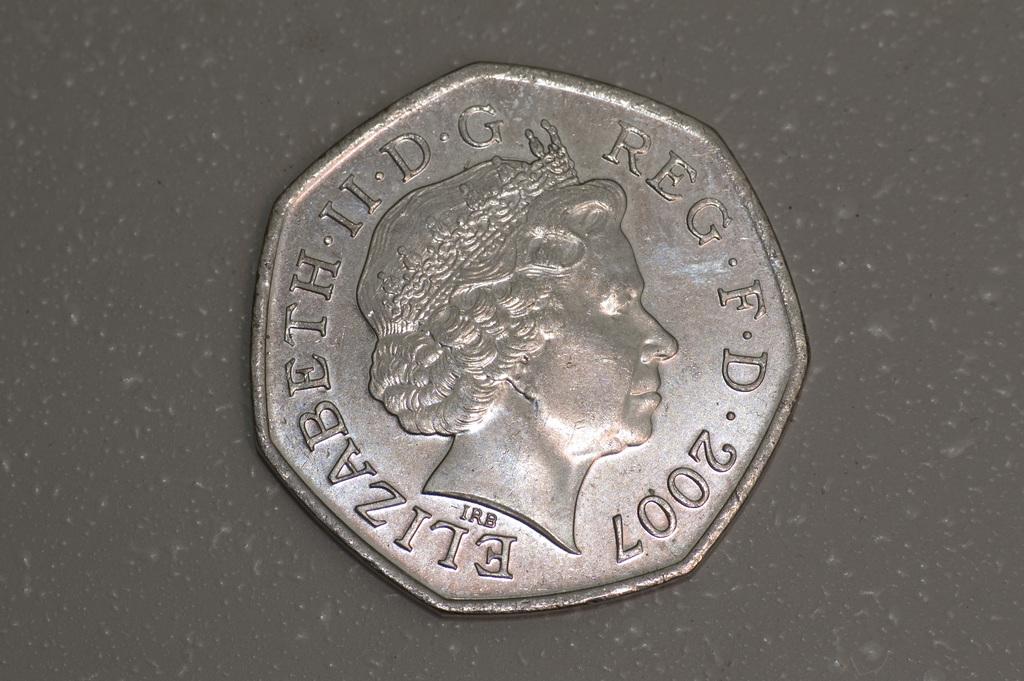Which is this coin minted?
Offer a terse response. 2007. What year was this coin made in?
Your answer should be compact. 2007. 